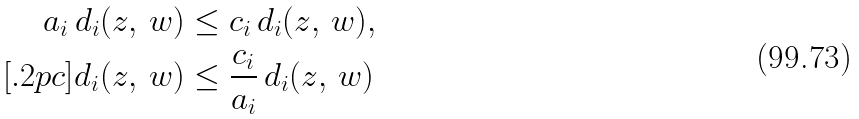Convert formula to latex. <formula><loc_0><loc_0><loc_500><loc_500>a _ { i } \, d _ { i } ( z , \, w ) & \leq c _ { i } \, d _ { i } ( z , \, w ) , \\ [ . 2 p c ] d _ { i } ( z , \, w ) & \leq \frac { c _ { i } } { a _ { i } } \, d _ { i } ( z , \, w )</formula> 